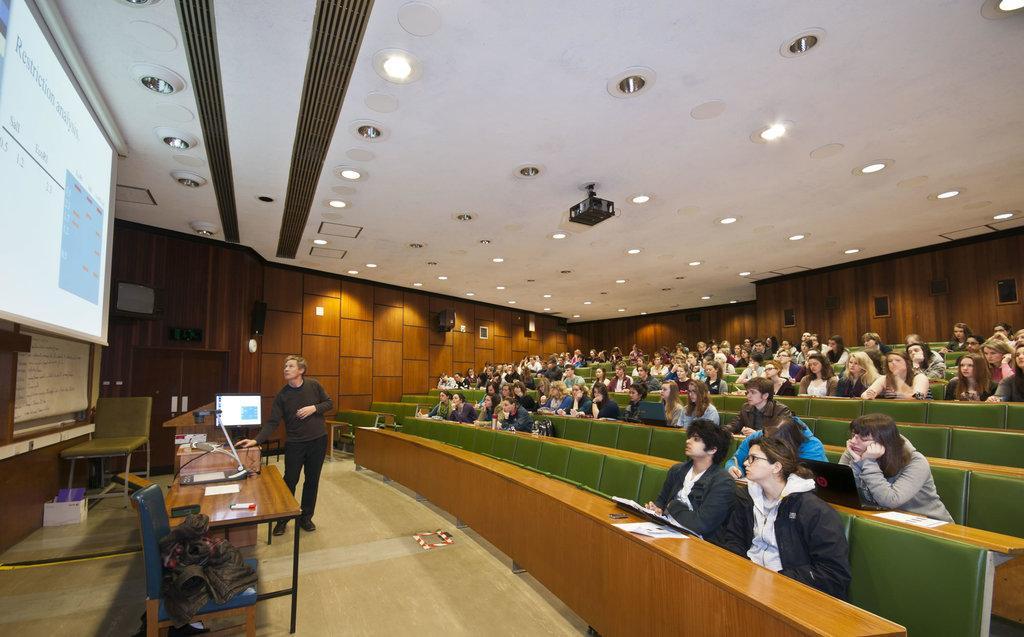In one or two sentences, can you explain what this image depicts? In the left top, a screen is visible. In the middle, a person is standing in front of the laptop and a table on which system is kept and a chair is visible. In the background middle, group of people sitting on the chair. A roof top is white in color on which lights are mounted. This image is taken in an auditorium hall. 